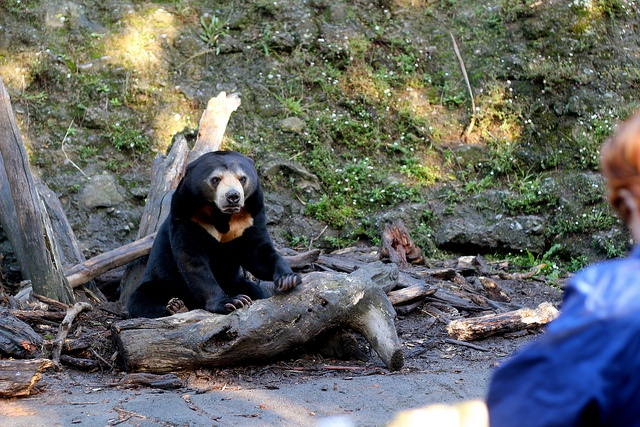Describe the objects in this image and their specific colors. I can see people in darkgreen, darkblue, blue, navy, and black tones and bear in darkgreen, black, navy, and gray tones in this image. 